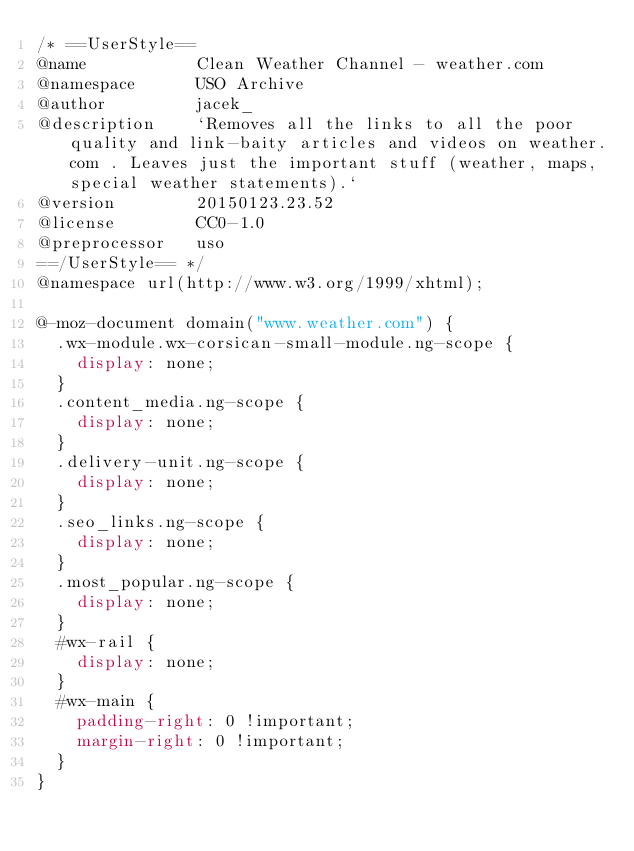<code> <loc_0><loc_0><loc_500><loc_500><_CSS_>/* ==UserStyle==
@name           Clean Weather Channel - weather.com
@namespace      USO Archive
@author         jacek_
@description    `Removes all the links to all the poor quality and link-baity articles and videos on weather.com . Leaves just the important stuff (weather, maps, special weather statements).`
@version        20150123.23.52
@license        CC0-1.0
@preprocessor   uso
==/UserStyle== */
@namespace url(http://www.w3.org/1999/xhtml);

@-moz-document domain("www.weather.com") {
  .wx-module.wx-corsican-small-module.ng-scope {
    display: none;
  }
  .content_media.ng-scope {
    display: none;
  }
  .delivery-unit.ng-scope {
    display: none;
  }
  .seo_links.ng-scope {
    display: none;
  }
  .most_popular.ng-scope {
    display: none;
  }
  #wx-rail {
    display: none;
  }
  #wx-main {
    padding-right: 0 !important;
    margin-right: 0 !important;
  }
}</code> 